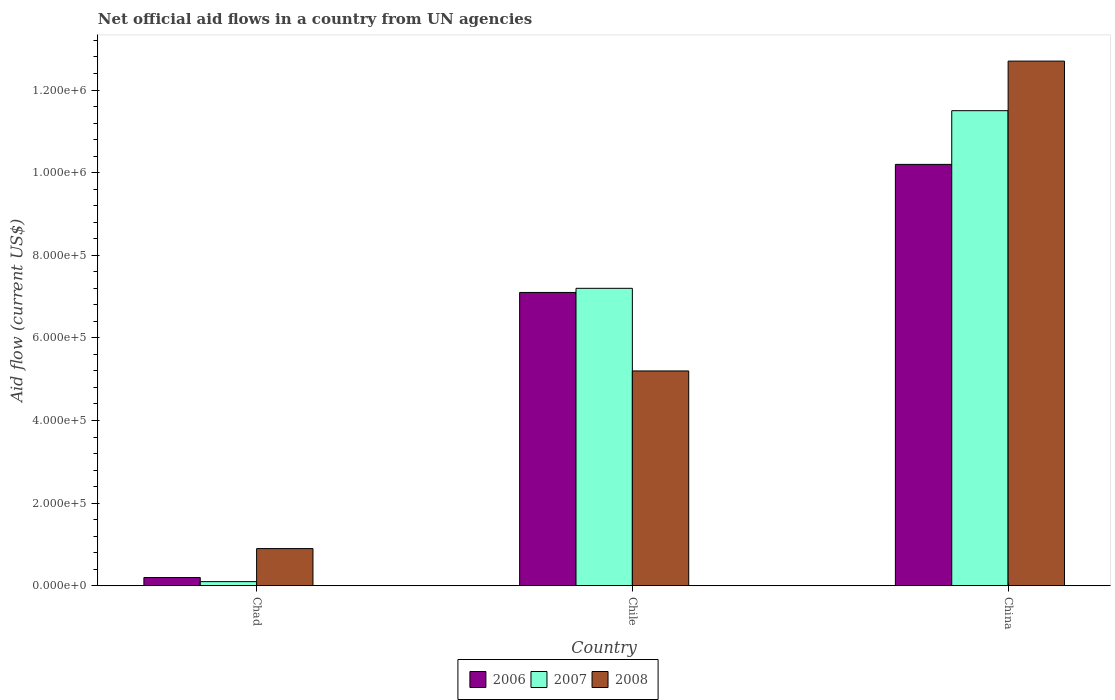How many different coloured bars are there?
Provide a short and direct response. 3. How many groups of bars are there?
Keep it short and to the point. 3. Are the number of bars on each tick of the X-axis equal?
Provide a short and direct response. Yes. How many bars are there on the 2nd tick from the left?
Give a very brief answer. 3. How many bars are there on the 3rd tick from the right?
Offer a very short reply. 3. What is the label of the 3rd group of bars from the left?
Ensure brevity in your answer.  China. What is the net official aid flow in 2008 in China?
Offer a terse response. 1.27e+06. Across all countries, what is the maximum net official aid flow in 2007?
Offer a terse response. 1.15e+06. In which country was the net official aid flow in 2008 minimum?
Give a very brief answer. Chad. What is the total net official aid flow in 2007 in the graph?
Keep it short and to the point. 1.88e+06. What is the difference between the net official aid flow in 2007 in Chad and that in Chile?
Offer a terse response. -7.10e+05. What is the average net official aid flow in 2008 per country?
Your answer should be very brief. 6.27e+05. What is the difference between the net official aid flow of/in 2008 and net official aid flow of/in 2007 in China?
Make the answer very short. 1.20e+05. What is the ratio of the net official aid flow in 2008 in Chad to that in Chile?
Provide a succinct answer. 0.17. Is the difference between the net official aid flow in 2008 in Chile and China greater than the difference between the net official aid flow in 2007 in Chile and China?
Keep it short and to the point. No. What is the difference between the highest and the second highest net official aid flow in 2008?
Make the answer very short. 7.50e+05. What is the difference between the highest and the lowest net official aid flow in 2007?
Your response must be concise. 1.14e+06. In how many countries, is the net official aid flow in 2008 greater than the average net official aid flow in 2008 taken over all countries?
Your answer should be compact. 1. What does the 1st bar from the left in Chile represents?
Ensure brevity in your answer.  2006. How many bars are there?
Your answer should be compact. 9. Are all the bars in the graph horizontal?
Provide a succinct answer. No. What is the title of the graph?
Provide a succinct answer. Net official aid flows in a country from UN agencies. What is the label or title of the X-axis?
Ensure brevity in your answer.  Country. What is the Aid flow (current US$) in 2006 in Chad?
Offer a very short reply. 2.00e+04. What is the Aid flow (current US$) of 2007 in Chad?
Provide a succinct answer. 10000. What is the Aid flow (current US$) in 2006 in Chile?
Provide a succinct answer. 7.10e+05. What is the Aid flow (current US$) in 2007 in Chile?
Your answer should be very brief. 7.20e+05. What is the Aid flow (current US$) of 2008 in Chile?
Keep it short and to the point. 5.20e+05. What is the Aid flow (current US$) in 2006 in China?
Provide a succinct answer. 1.02e+06. What is the Aid flow (current US$) in 2007 in China?
Your response must be concise. 1.15e+06. What is the Aid flow (current US$) in 2008 in China?
Give a very brief answer. 1.27e+06. Across all countries, what is the maximum Aid flow (current US$) of 2006?
Keep it short and to the point. 1.02e+06. Across all countries, what is the maximum Aid flow (current US$) in 2007?
Your answer should be compact. 1.15e+06. Across all countries, what is the maximum Aid flow (current US$) of 2008?
Give a very brief answer. 1.27e+06. Across all countries, what is the minimum Aid flow (current US$) in 2007?
Your response must be concise. 10000. Across all countries, what is the minimum Aid flow (current US$) in 2008?
Ensure brevity in your answer.  9.00e+04. What is the total Aid flow (current US$) of 2006 in the graph?
Ensure brevity in your answer.  1.75e+06. What is the total Aid flow (current US$) in 2007 in the graph?
Your answer should be very brief. 1.88e+06. What is the total Aid flow (current US$) in 2008 in the graph?
Make the answer very short. 1.88e+06. What is the difference between the Aid flow (current US$) of 2006 in Chad and that in Chile?
Provide a short and direct response. -6.90e+05. What is the difference between the Aid flow (current US$) of 2007 in Chad and that in Chile?
Make the answer very short. -7.10e+05. What is the difference between the Aid flow (current US$) of 2008 in Chad and that in Chile?
Keep it short and to the point. -4.30e+05. What is the difference between the Aid flow (current US$) of 2007 in Chad and that in China?
Your response must be concise. -1.14e+06. What is the difference between the Aid flow (current US$) in 2008 in Chad and that in China?
Your answer should be compact. -1.18e+06. What is the difference between the Aid flow (current US$) in 2006 in Chile and that in China?
Keep it short and to the point. -3.10e+05. What is the difference between the Aid flow (current US$) in 2007 in Chile and that in China?
Ensure brevity in your answer.  -4.30e+05. What is the difference between the Aid flow (current US$) of 2008 in Chile and that in China?
Ensure brevity in your answer.  -7.50e+05. What is the difference between the Aid flow (current US$) in 2006 in Chad and the Aid flow (current US$) in 2007 in Chile?
Your answer should be compact. -7.00e+05. What is the difference between the Aid flow (current US$) of 2006 in Chad and the Aid flow (current US$) of 2008 in Chile?
Ensure brevity in your answer.  -5.00e+05. What is the difference between the Aid flow (current US$) in 2007 in Chad and the Aid flow (current US$) in 2008 in Chile?
Make the answer very short. -5.10e+05. What is the difference between the Aid flow (current US$) of 2006 in Chad and the Aid flow (current US$) of 2007 in China?
Your answer should be very brief. -1.13e+06. What is the difference between the Aid flow (current US$) in 2006 in Chad and the Aid flow (current US$) in 2008 in China?
Offer a very short reply. -1.25e+06. What is the difference between the Aid flow (current US$) in 2007 in Chad and the Aid flow (current US$) in 2008 in China?
Provide a short and direct response. -1.26e+06. What is the difference between the Aid flow (current US$) of 2006 in Chile and the Aid flow (current US$) of 2007 in China?
Offer a very short reply. -4.40e+05. What is the difference between the Aid flow (current US$) in 2006 in Chile and the Aid flow (current US$) in 2008 in China?
Your answer should be very brief. -5.60e+05. What is the difference between the Aid flow (current US$) of 2007 in Chile and the Aid flow (current US$) of 2008 in China?
Offer a terse response. -5.50e+05. What is the average Aid flow (current US$) of 2006 per country?
Ensure brevity in your answer.  5.83e+05. What is the average Aid flow (current US$) in 2007 per country?
Your response must be concise. 6.27e+05. What is the average Aid flow (current US$) in 2008 per country?
Provide a short and direct response. 6.27e+05. What is the difference between the Aid flow (current US$) of 2006 and Aid flow (current US$) of 2007 in Chad?
Ensure brevity in your answer.  10000. What is the difference between the Aid flow (current US$) of 2006 and Aid flow (current US$) of 2008 in Chad?
Keep it short and to the point. -7.00e+04. What is the difference between the Aid flow (current US$) of 2007 and Aid flow (current US$) of 2008 in Chad?
Keep it short and to the point. -8.00e+04. What is the difference between the Aid flow (current US$) in 2006 and Aid flow (current US$) in 2008 in Chile?
Offer a terse response. 1.90e+05. What is the ratio of the Aid flow (current US$) in 2006 in Chad to that in Chile?
Your answer should be very brief. 0.03. What is the ratio of the Aid flow (current US$) in 2007 in Chad to that in Chile?
Offer a very short reply. 0.01. What is the ratio of the Aid flow (current US$) of 2008 in Chad to that in Chile?
Make the answer very short. 0.17. What is the ratio of the Aid flow (current US$) of 2006 in Chad to that in China?
Provide a succinct answer. 0.02. What is the ratio of the Aid flow (current US$) of 2007 in Chad to that in China?
Keep it short and to the point. 0.01. What is the ratio of the Aid flow (current US$) of 2008 in Chad to that in China?
Your answer should be very brief. 0.07. What is the ratio of the Aid flow (current US$) of 2006 in Chile to that in China?
Keep it short and to the point. 0.7. What is the ratio of the Aid flow (current US$) of 2007 in Chile to that in China?
Offer a terse response. 0.63. What is the ratio of the Aid flow (current US$) of 2008 in Chile to that in China?
Your answer should be very brief. 0.41. What is the difference between the highest and the second highest Aid flow (current US$) in 2006?
Offer a terse response. 3.10e+05. What is the difference between the highest and the second highest Aid flow (current US$) of 2008?
Your answer should be very brief. 7.50e+05. What is the difference between the highest and the lowest Aid flow (current US$) in 2006?
Provide a short and direct response. 1.00e+06. What is the difference between the highest and the lowest Aid flow (current US$) in 2007?
Keep it short and to the point. 1.14e+06. What is the difference between the highest and the lowest Aid flow (current US$) of 2008?
Offer a terse response. 1.18e+06. 